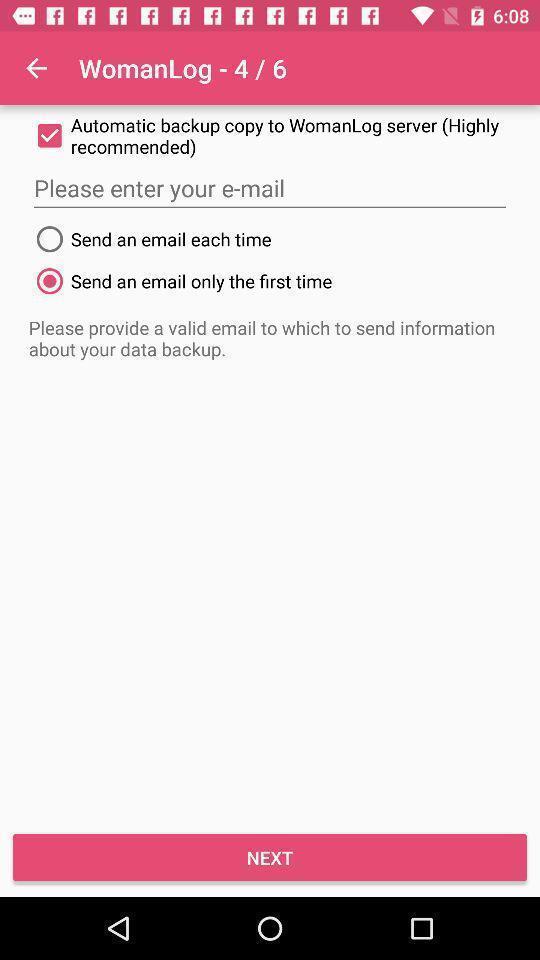Describe this image in words. Pop-up is showing about e-mail. 